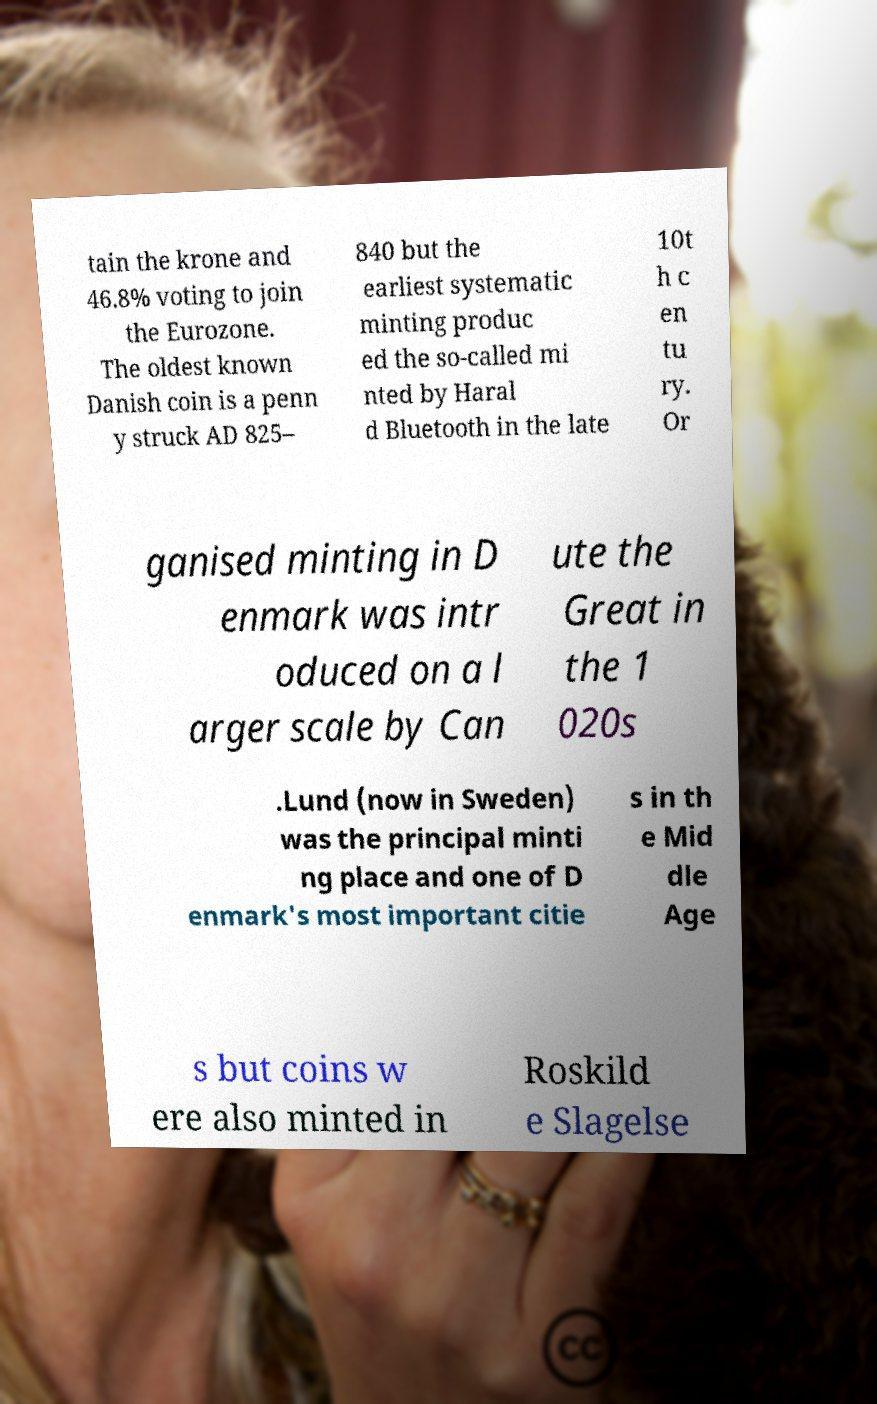Please read and relay the text visible in this image. What does it say? tain the krone and 46.8% voting to join the Eurozone. The oldest known Danish coin is a penn y struck AD 825– 840 but the earliest systematic minting produc ed the so-called mi nted by Haral d Bluetooth in the late 10t h c en tu ry. Or ganised minting in D enmark was intr oduced on a l arger scale by Can ute the Great in the 1 020s .Lund (now in Sweden) was the principal minti ng place and one of D enmark's most important citie s in th e Mid dle Age s but coins w ere also minted in Roskild e Slagelse 